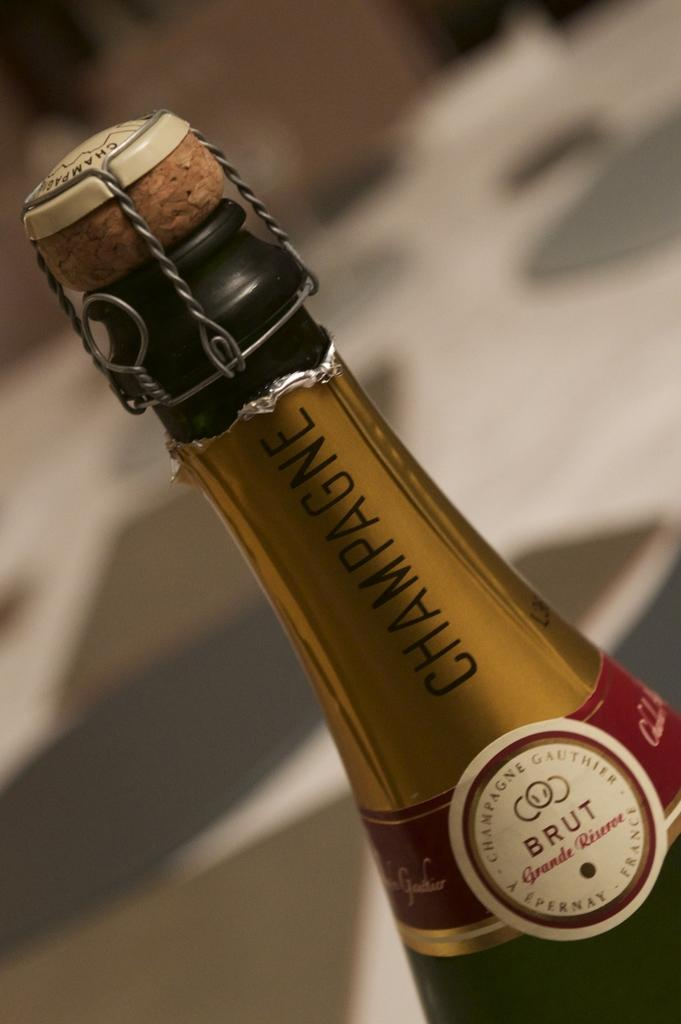<image>
Present a compact description of the photo's key features. THE WRAPED CORK TOP BOTTLE OF BRUT CHAMPAGNE 